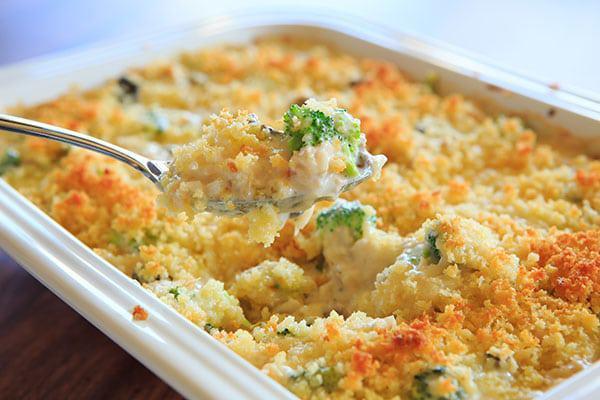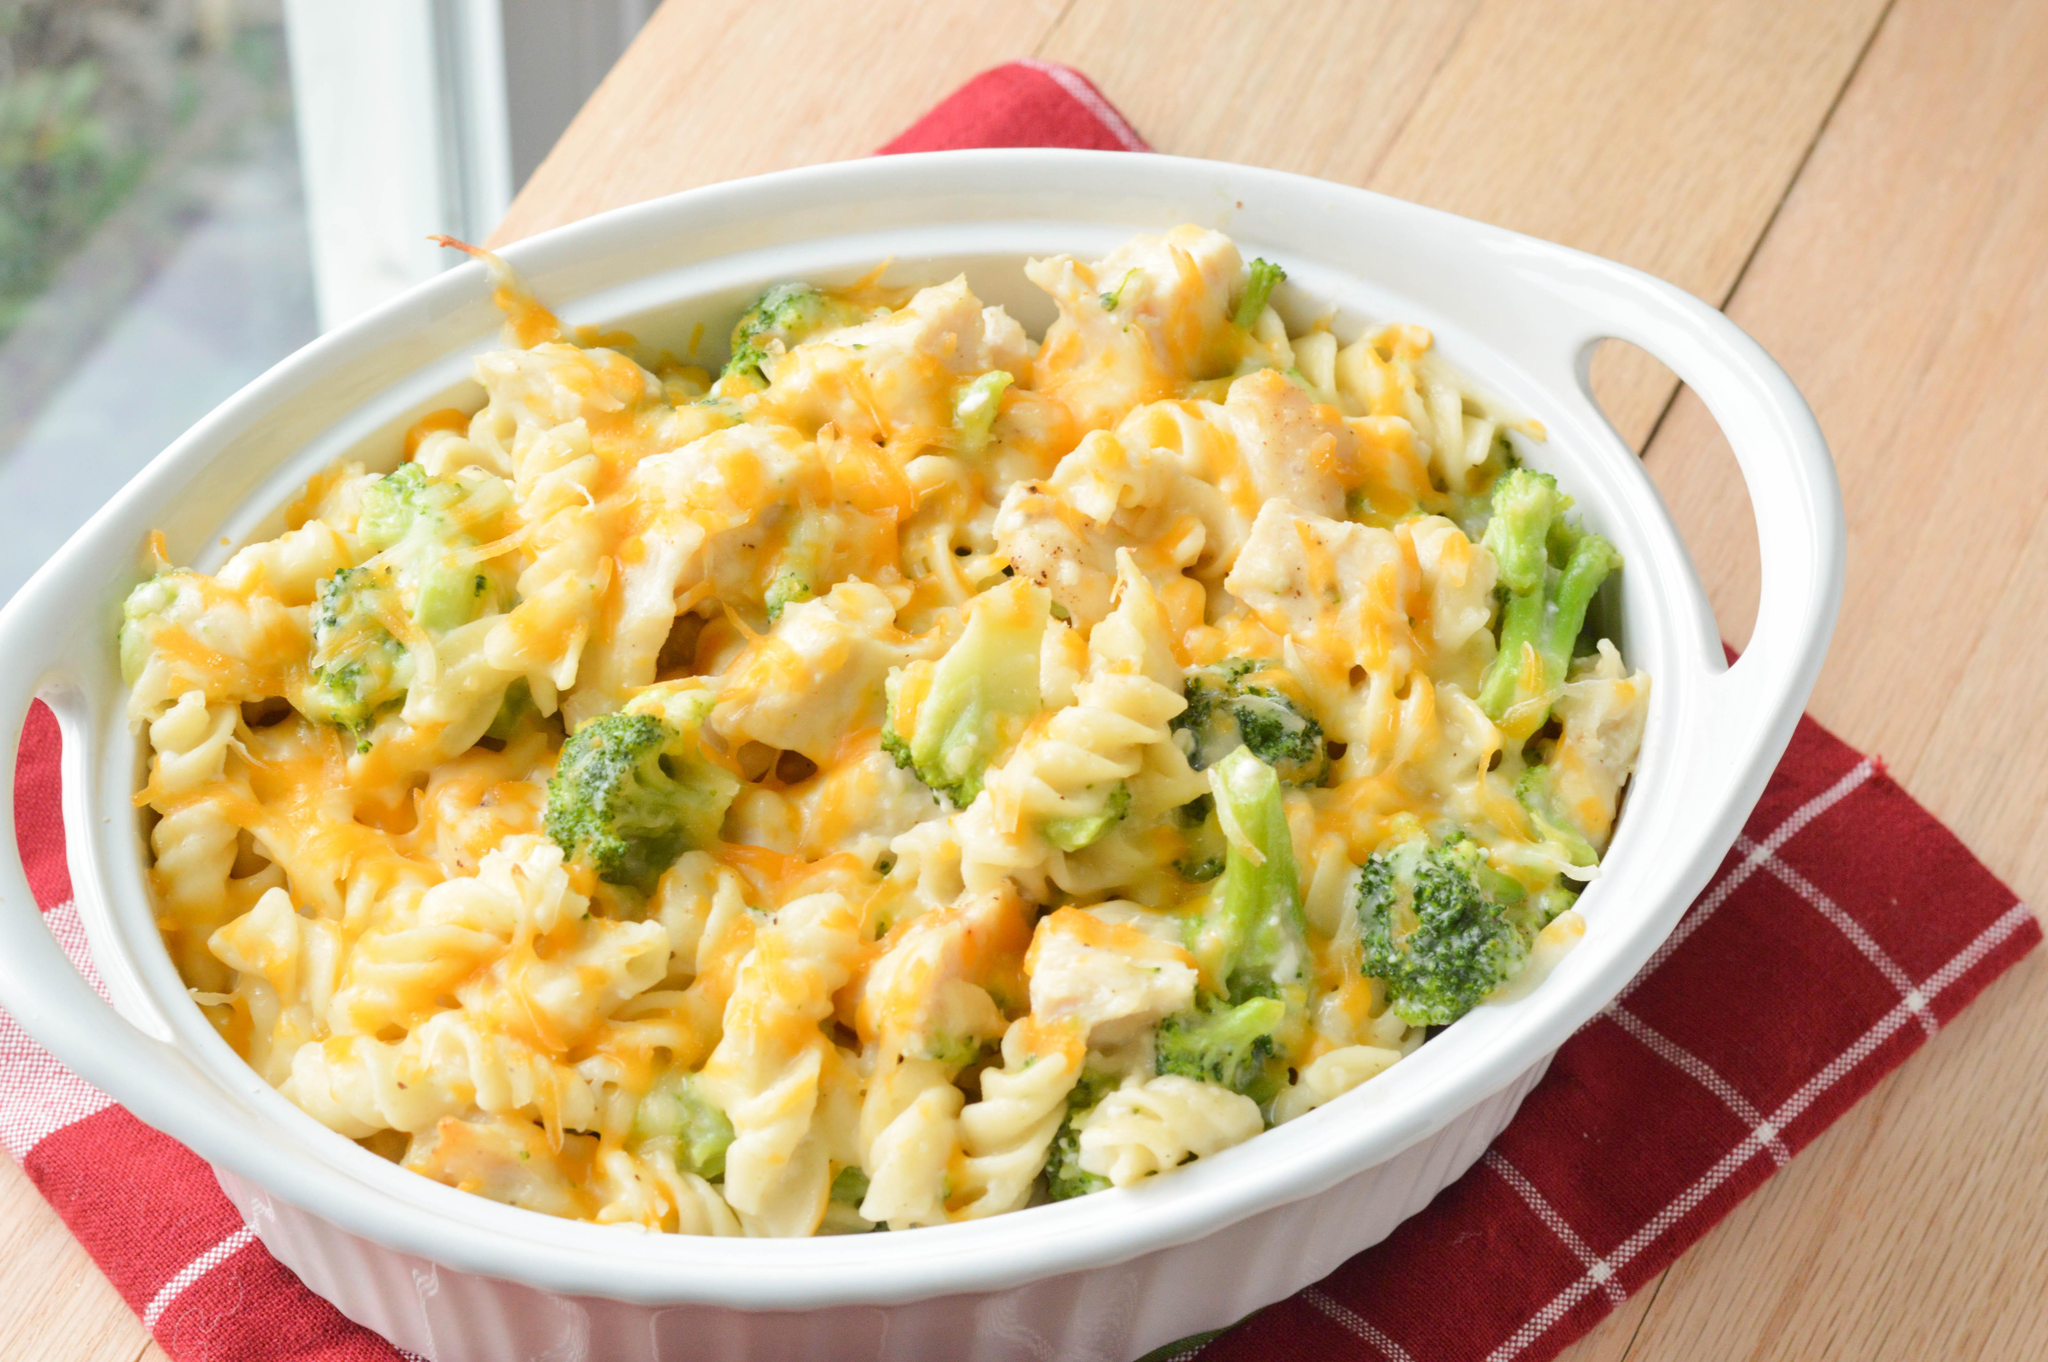The first image is the image on the left, the second image is the image on the right. Considering the images on both sides, is "In one of the images there is a broccoli casserole with a large serving spoon in it." valid? Answer yes or no. Yes. 